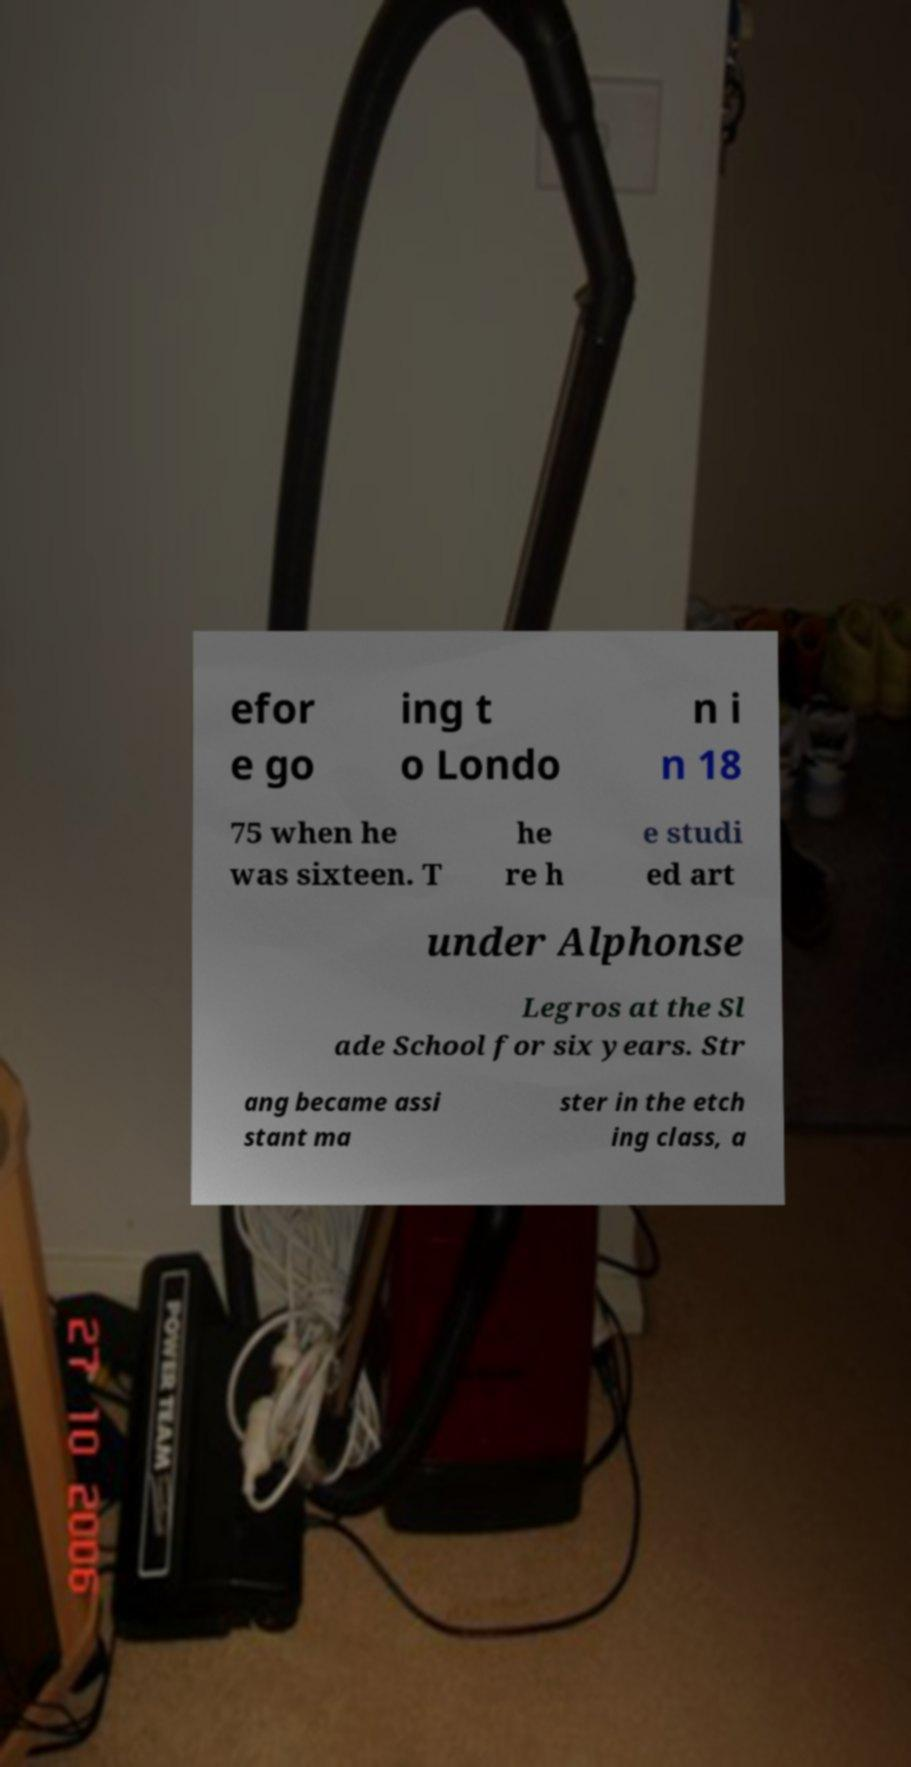Can you read and provide the text displayed in the image?This photo seems to have some interesting text. Can you extract and type it out for me? efor e go ing t o Londo n i n 18 75 when he was sixteen. T he re h e studi ed art under Alphonse Legros at the Sl ade School for six years. Str ang became assi stant ma ster in the etch ing class, a 